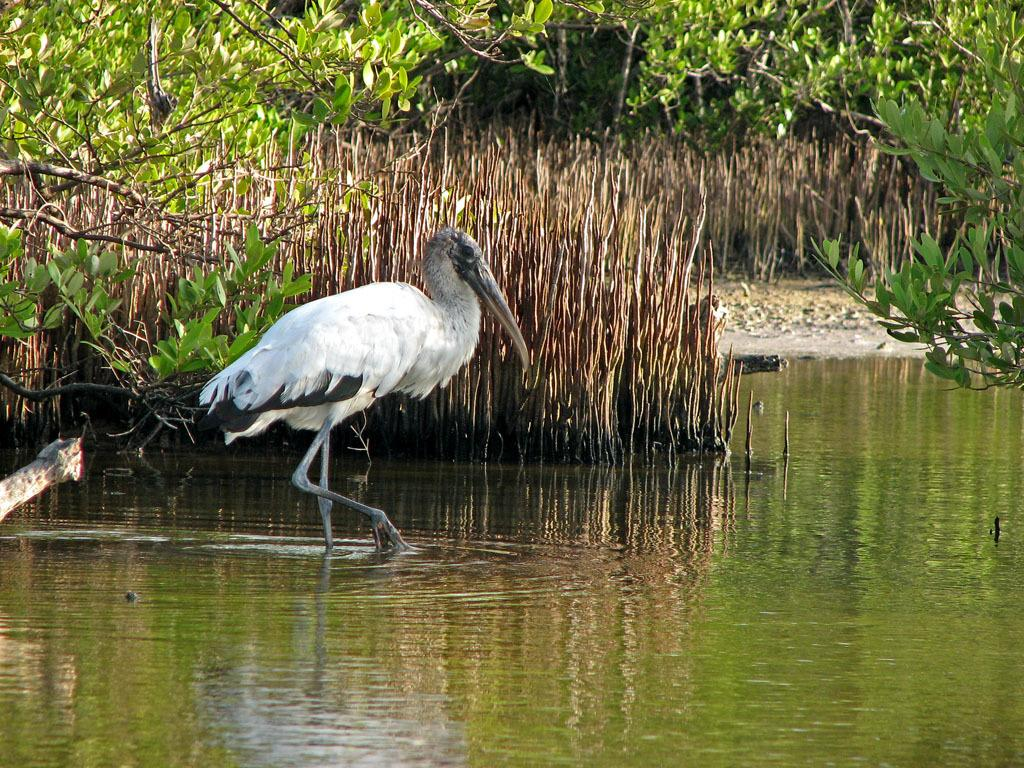What type of animals are in the image? There are ibis in the image. Where are the ibis located? The ibis are in the water. What can be seen in the background of the image? There are plants and trees in the background of the image. What type of lamp is visible in the image? There is no lamp present in the image. What thought might the ibis be having in the image? It is impossible to determine the thoughts of the ibis in the image, as they are animals and do not have the ability to think or express thoughts like humans. 